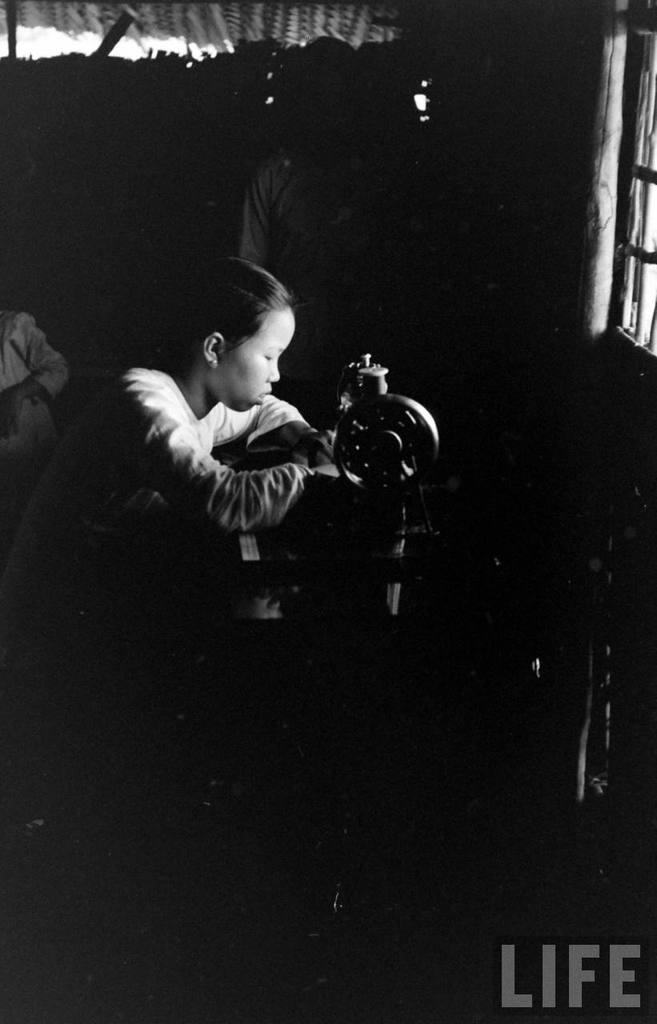Could you give a brief overview of what you see in this image? In this image I can see the picture which is very dark. I can see a person sitting in front of a sewing machine. I can see the window, a wooden pole and few persons in the background. 